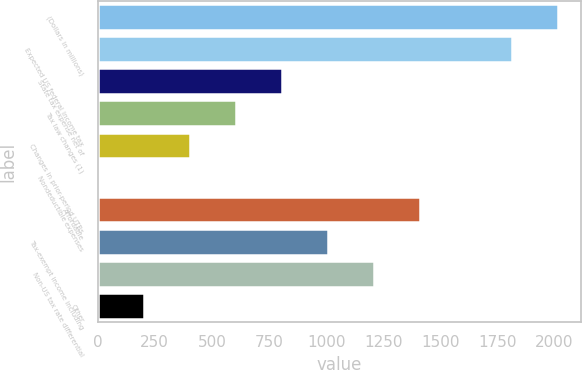<chart> <loc_0><loc_0><loc_500><loc_500><bar_chart><fcel>(Dollars in millions)<fcel>Expected US federal income tax<fcel>State tax expense net of<fcel>Tax law changes (1)<fcel>Changes in prior-period UTBs<fcel>Nondeductible expenses<fcel>Affordable<fcel>Tax-exempt income including<fcel>Non-US tax rate differential<fcel>Other<nl><fcel>2015<fcel>1813.51<fcel>806.06<fcel>604.57<fcel>403.08<fcel>0.1<fcel>1410.53<fcel>1007.55<fcel>1209.04<fcel>201.59<nl></chart> 